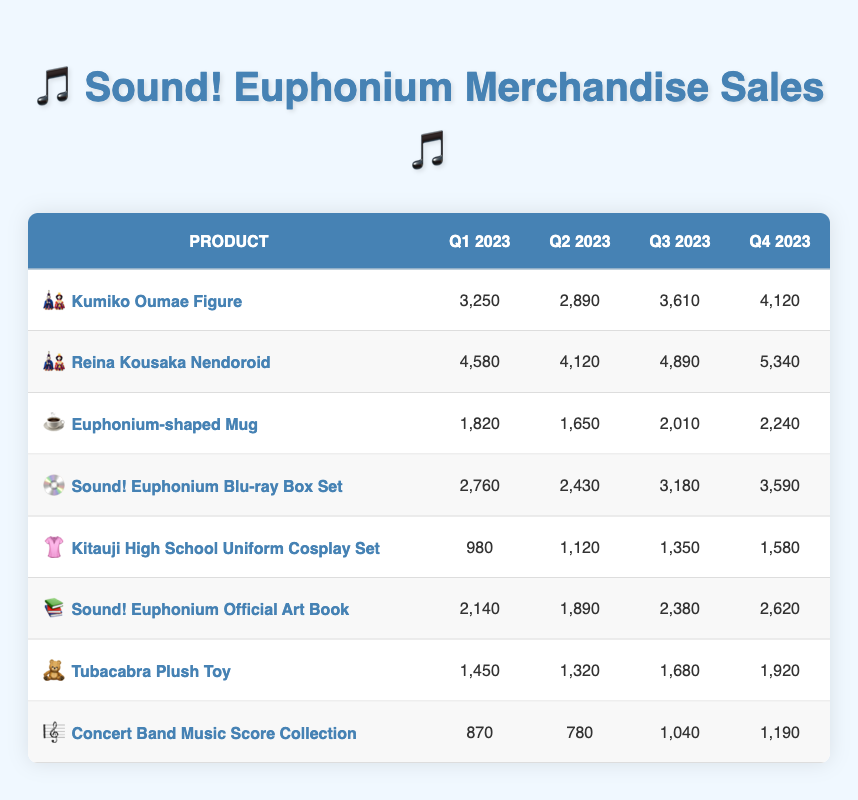What were the sales figures for the Reina Kousaka Nendoroid in Q3 2023? The sales figure for Reina Kousaka Nendoroid in Q3 2023 can be found directly in the table. Under the column for Q3 2023, the value listed for this product is 4890.
Answer: 4890 Which product had the highest sales in Q4 2023? To find the product with the highest sales in Q4 2023, we compare the figures for all products in the Q4 2023 column. The highest number is 5340 for Reina Kousaka Nendoroid.
Answer: Reina Kousaka Nendoroid What is the percentage increase in sales for the Sound! Euphonium Blu-ray Box Set from Q1 to Q4 2023? First, we find the sales figures for Q1 and Q4 2023. In Q1, it sold 2760 units, and in Q4, it sold 3590 units. The increase is 3590 - 2760 = 830 units. To find the percentage increase: (830 / 2760) * 100 = 30.07%.
Answer: 30.07% Did the Kitauji High School Uniform Cosplay Set experience a decline in sales from Q2 to Q3 2023? We check the sales figures for the Kitauji High School Uniform Cosplay Set in Q2 and Q3 2023. The Q2 sales were 1120, and Q3 sales were 1350. Since 1350 is greater than 1120, it did not experience a decline.
Answer: No What are the total sales figures for the Euphonium-shaped Mug across all quarters? To find the total sales for the Euphonium-shaped Mug, we add the figures for all four quarters: 1820 + 1650 + 2010 + 2240 = 8320.
Answer: 8320 Which product had the lowest sales in Q1 2023? We need to examine the sales figures for Q1 2023 for all products. The lowest figure in that column is 870, associated with the Concert Band Music Score Collection.
Answer: Concert Band Music Score Collection What is the average sales figure for all products in Q2 2023? We sum the sales figures for all products in Q2 2023: 2890 + 4120 + 1650 + 2430 + 1120 + 1890 + 1320 + 780 = 13380. There are 8 products, so to find the average: 13380 / 8 = 1672.5.
Answer: 1672.5 Has the sales figure for the Euphonium-shaped Mug always been below 2500 units? We look at the sales figures for the Euphonium-shaped Mug across all quarters: 1820 (Q1), 1650 (Q2), 2010 (Q3), and 2240 (Q4). All are indeed below 2500, confirming the statement.
Answer: Yes 